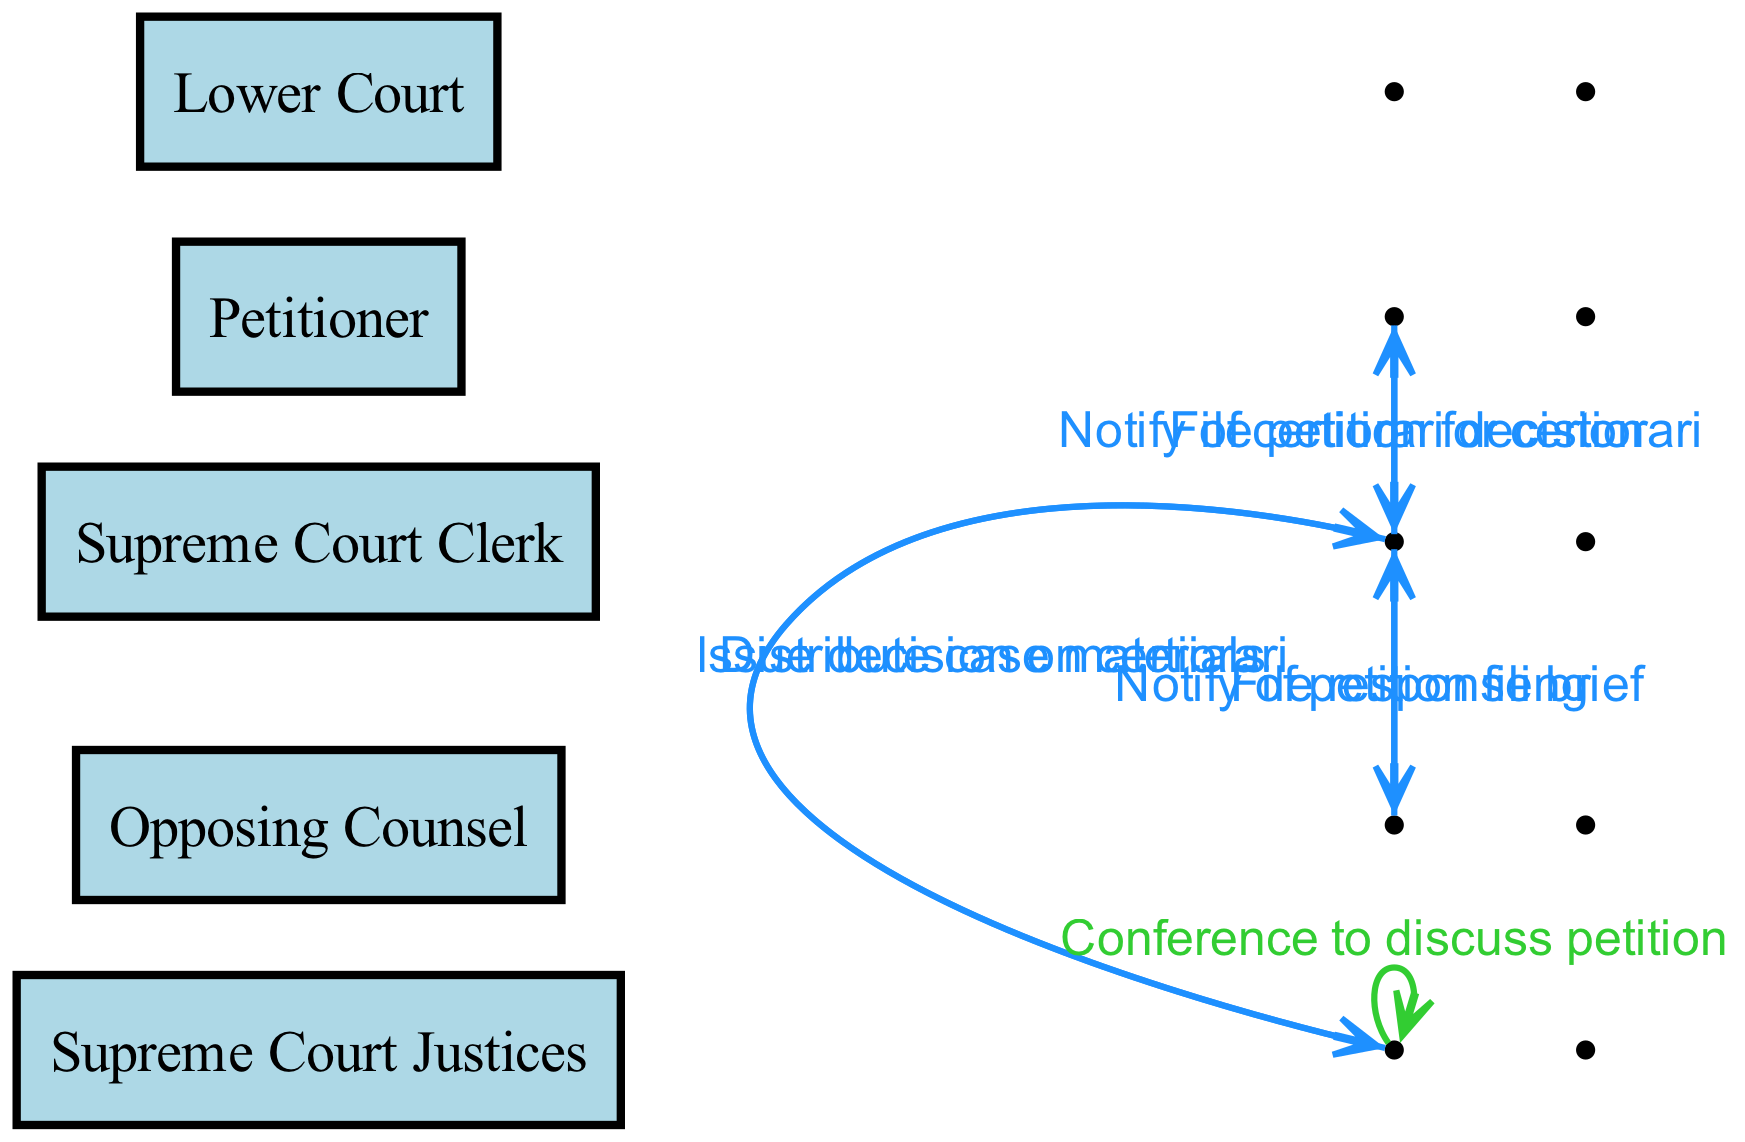What is the first action taken in the sequence? The first action in the sequence is "File petition for certiorari" performed by the Petitioner. This is the starting point of the process depicted in the diagram.
Answer: File petition for certiorari How many actors are involved in this diagram? The diagram lists five actors involved in the process. These actors are Petitioner, Lower Court, Supreme Court Clerk, Opposing Counsel, and Supreme Court Justices.
Answer: Five Who does the Supreme Court Clerk notify after receiving the petition? The Supreme Court Clerk notifies the Opposing Counsel following the filing of the petition. This action is explicitly depicted in the sequence of interactions.
Answer: Opposing Counsel What is the last action taken by the Supreme Court Clerk? The last action taken by the Supreme Court Clerk is to notify the Petitioner of the certiorari decision after the Supreme Court Justices have issued their decision.
Answer: Notify of certiorari decision Which actor issues the decision on certiorari? The decision on certiorari is issued by the Supreme Court Justices. This indicates that they are responsible for determining whether to hear a case.
Answer: Supreme Court Justices What action occurs after the Opposing Counsel files a response brief? After the Opposing Counsel files a response brief, the next action is for the Supreme Court Clerk to distribute case materials to the Supreme Court Justices. This follows the planned sequence of interactions.
Answer: Distribute case materials How does the Supreme Court Clerk facilitate communication with the Petitioner? The Supreme Court Clerk facilitates communication with the Petitioner by sending a notification regarding the certiorari decision, which is the final step in the sequence relevant to the Petitioner.
Answer: Notify of certiorari decision What is the purpose of the conference among the Supreme Court Justices? The conference among the Supreme Court Justices serves the purpose of discussing the petition. This indicates a deliberative stage where they consider the merits of the case before making a decision.
Answer: Discuss petition In which direction does the notification from the Supreme Court Clerk to the Opposing Counsel flow? The notification from the Supreme Court Clerk to the Opposing Counsel flows from the Supreme Court Clerk towards the Opposing Counsel, indicating that the Clerk is informing the Counsel about the petition filing.
Answer: From Clerk to Opposing Counsel 